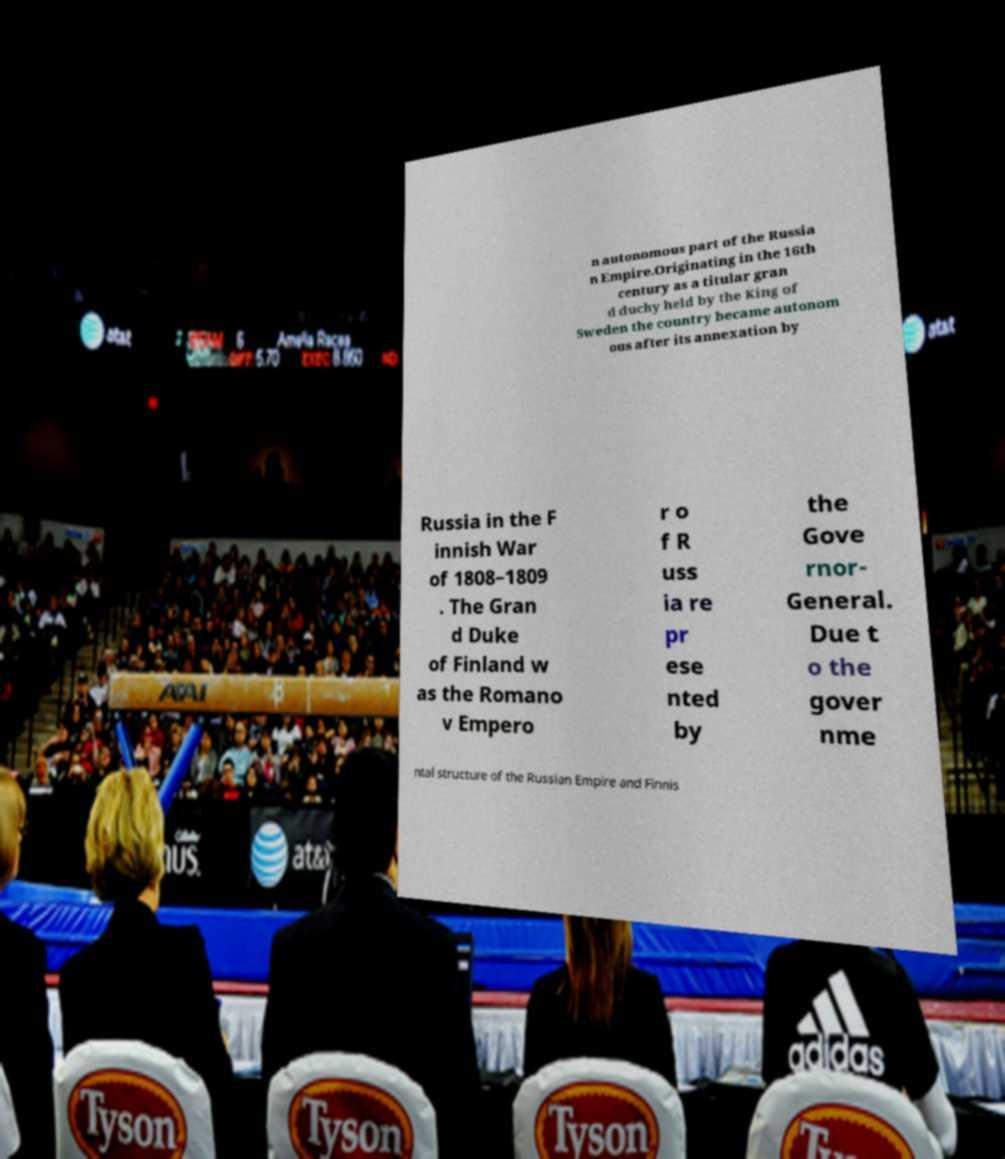Can you accurately transcribe the text from the provided image for me? n autonomous part of the Russia n Empire.Originating in the 16th century as a titular gran d duchy held by the King of Sweden the country became autonom ous after its annexation by Russia in the F innish War of 1808–1809 . The Gran d Duke of Finland w as the Romano v Empero r o f R uss ia re pr ese nted by the Gove rnor- General. Due t o the gover nme ntal structure of the Russian Empire and Finnis 